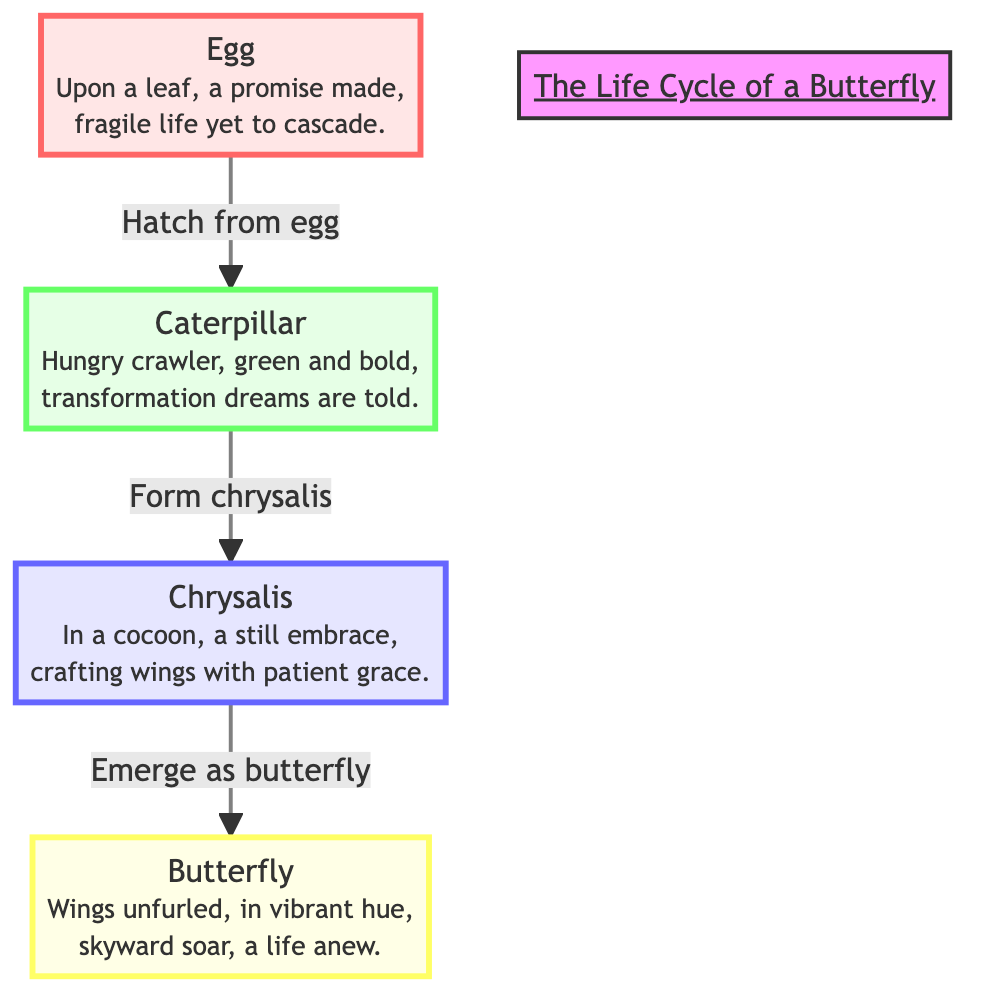What are the four stages of the butterfly's life cycle? The diagram shows four distinct stages: Egg, Caterpillar, Chrysalis, and Butterfly. Each stage is represented clearly with labels and poetic narrations.
Answer: Egg, Caterpillar, Chrysalis, Butterfly What color represents the chrysalis stage? The color associated with the chrysalis stage in the diagram is a light blue, indicated by the fill color of the "Chrysalis" node.
Answer: Light blue How many transitions are there between the stages in the life cycle? There are three arrows connecting the four stages: Egg to Caterpillar, Caterpillar to Chrysalis, and Chrysalis to Butterfly. Thus, there are three transitions.
Answer: Three What does the caterpillar do before forming the chrysalis? According to the flow of the diagram, before forming the chrysalis, the Caterpillar progresses from a hungry crawler, indicating it nourishes itself before moving to the next stage.
Answer: Form chrysalis What happens after the chrysalis stage? After the chrysalis stage, the diagram indicates that the next stage is the emergence of the Butterfly, showcasing the life cycle progression.
Answer: Emerge as butterfly What poetic theme is associated with the egg stage? The poetic narration associated with the egg stage focuses on fragility and the promise of life, suggesting the beginning of the transformation.
Answer: Fragile life yet to cascade How does the diagram describe the caterpillar? The diagram describes the caterpillar as a "hungry crawler, green and bold," emphasizing its active role in the transformation before the chrysalis stage.
Answer: Hungry crawler, green and bold Which stage is described as "crafting wings with patient grace"? The stage that is described in this manner is the Chrysalis. The wording highlights the calm and transformative nature of this phase.
Answer: Chrysalis What is the final stage of the butterfly's life cycle? The final stage in the life cycle of the butterfly, as depicted in the diagram, is the Butterfly, where it emerges to begin its new existence.
Answer: Butterfly 